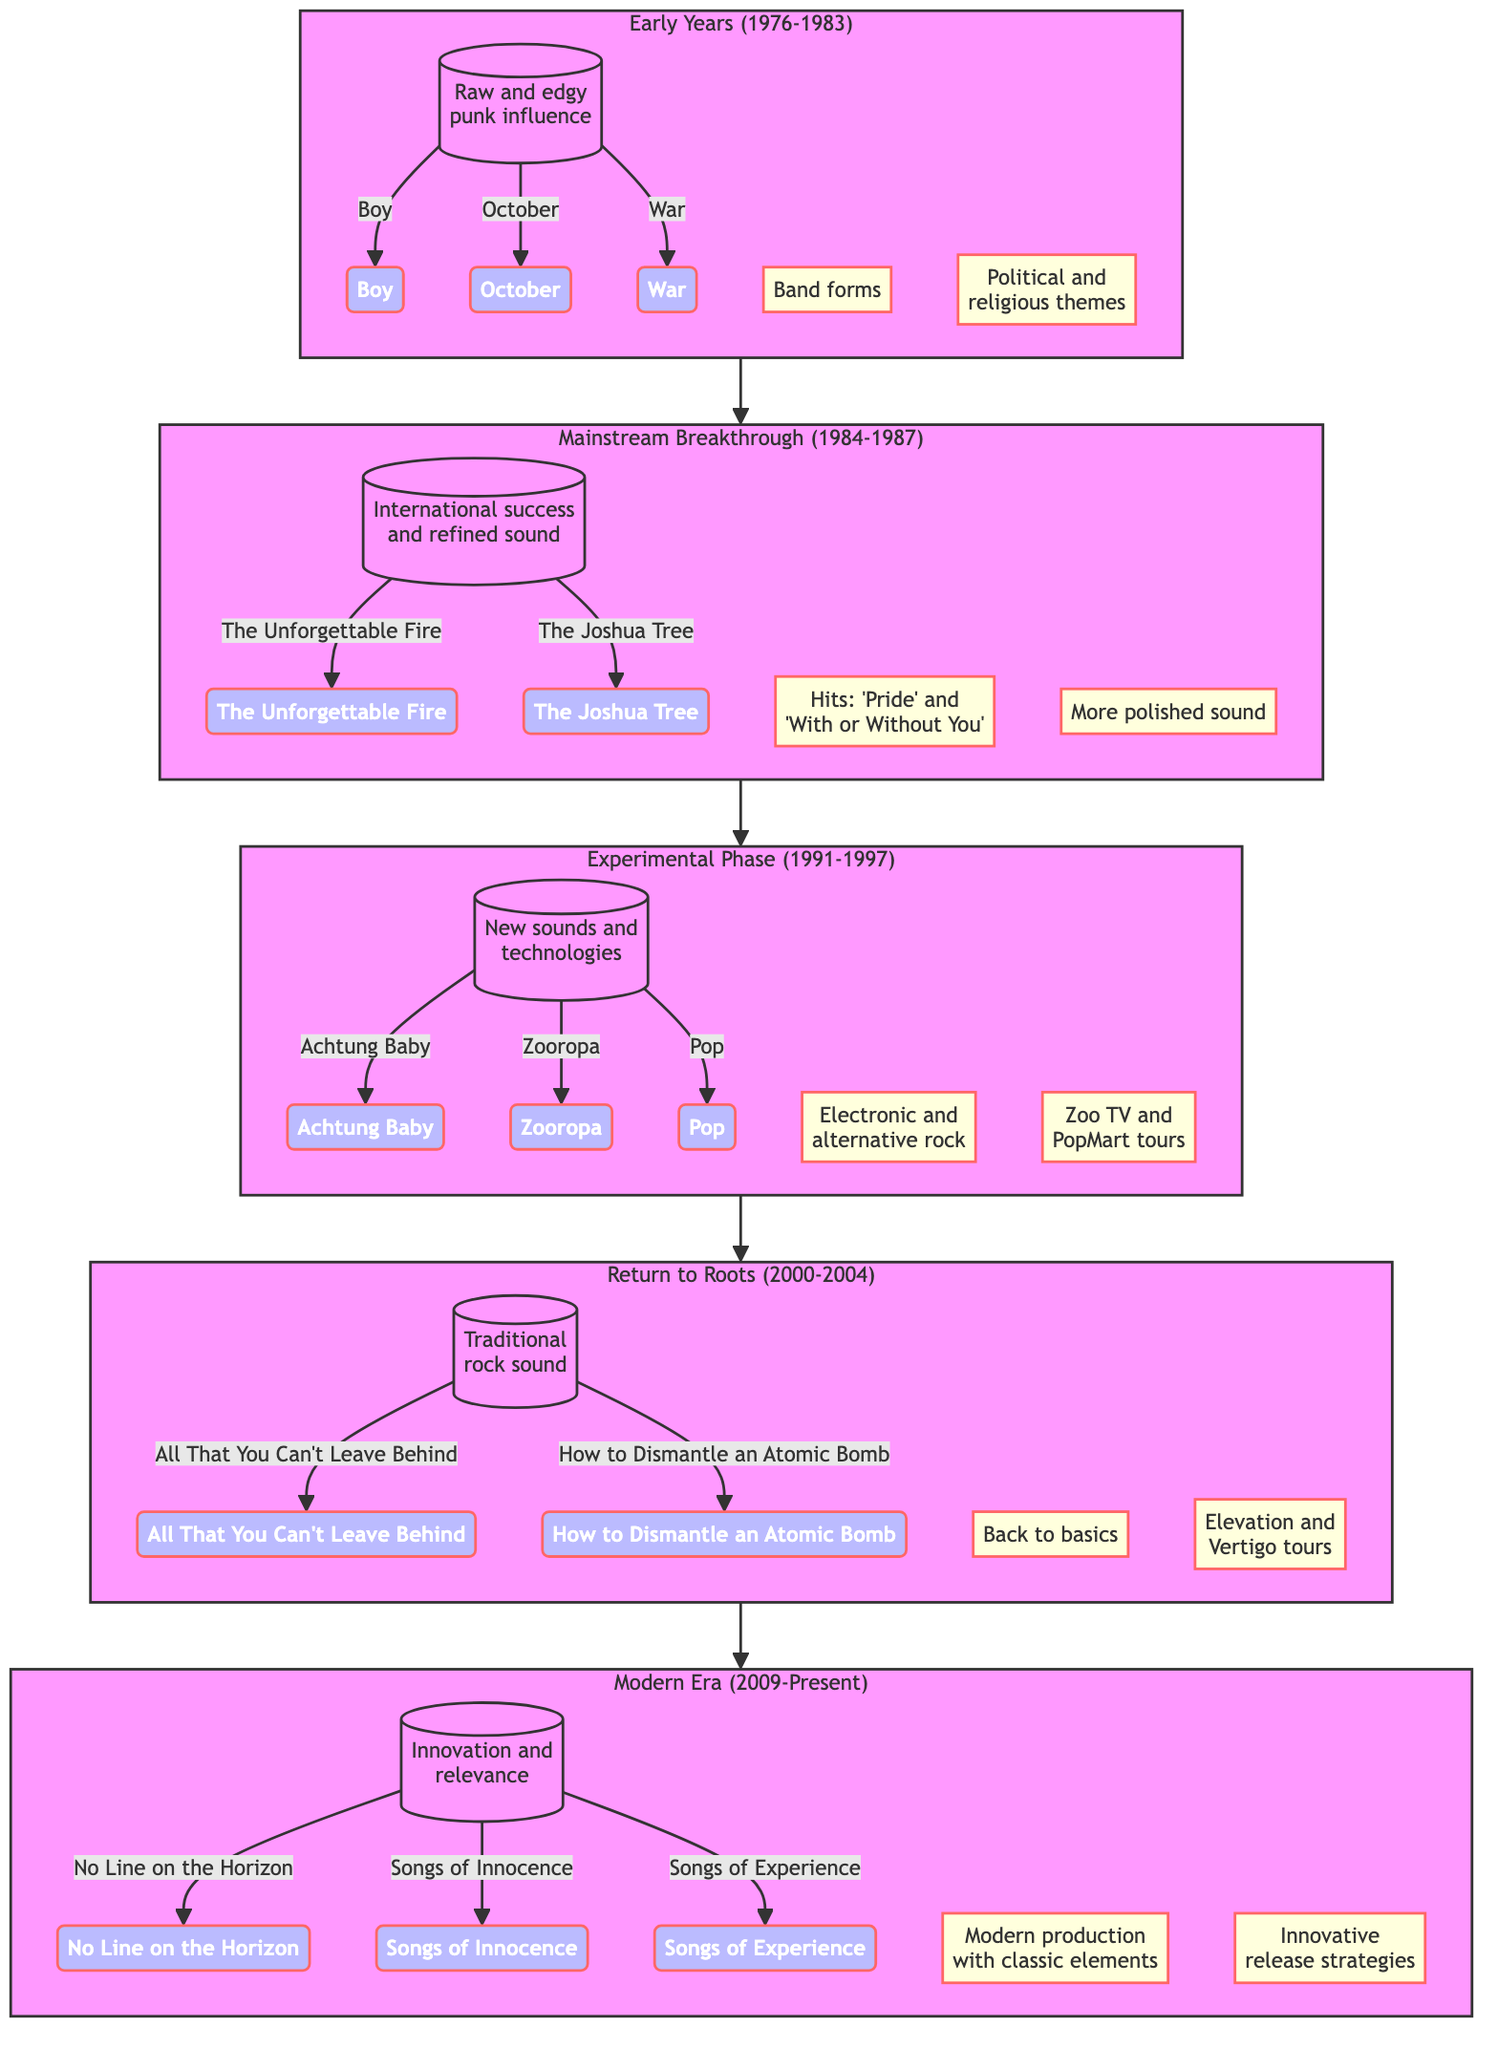What is the duration of the Early Years stage? The diagram indicates that the Early Years stage spans from 1976 to 1983. This information can be found within the "duration" label in the Early Years section of the diagram.
Answer: 1976-1983 How many albums are listed in the Modern Era stage? In the Modern Era stage, there are three albums mentioned: "No Line on the Horizon," "Songs of Innocence," and "Songs of Experience." This can be derived by counting the album nodes connected to the Modern Era section.
Answer: 3 Which stage includes the album "Achtung Baby"? The album "Achtung Baby" is part of the Experimental Phase. This is determined by identifying the album listed in the Experimental Phase section of the diagram.
Answer: Experimental Phase What key note is associated with the Mainstream Breakthrough stage? One of the key notes in the Mainstream Breakthrough stage is "Hits: 'Pride' and 'With or Without You'." This information can be found within the key notes listed in that section.
Answer: Hits: 'Pride' and 'With or Without You' What is one notable tour from the Experimental Phase? The diagram lists "Zoo TV" as one of the notable tours from the Experimental Phase. This can be verified by examining the key notes under that stage.
Answer: Zoo TV Which two stages follow the Return to Roots? The stages that follow the Return to Roots are Modern Era and Mainstream Breakthrough, as the diagram shows a flow from Return to Roots leading to Modern Era, indicating the order of evolution.
Answer: Modern Era, Mainstream Breakthrough How many key notes are presented in the Return to Roots stage? The Return to Roots stage has two key notes associated with it: "Back to basics" and "Elevation and Vertigo tours." This can be seen by counting the key notes listed in that section.
Answer: 2 What is the common theme during the Early Years? The common theme during the Early Years is described as "Raw sound with political and religious themes." This is explicitly mentioned in the key notes of the Early Years section.
Answer: Raw sound with political and religious themes 